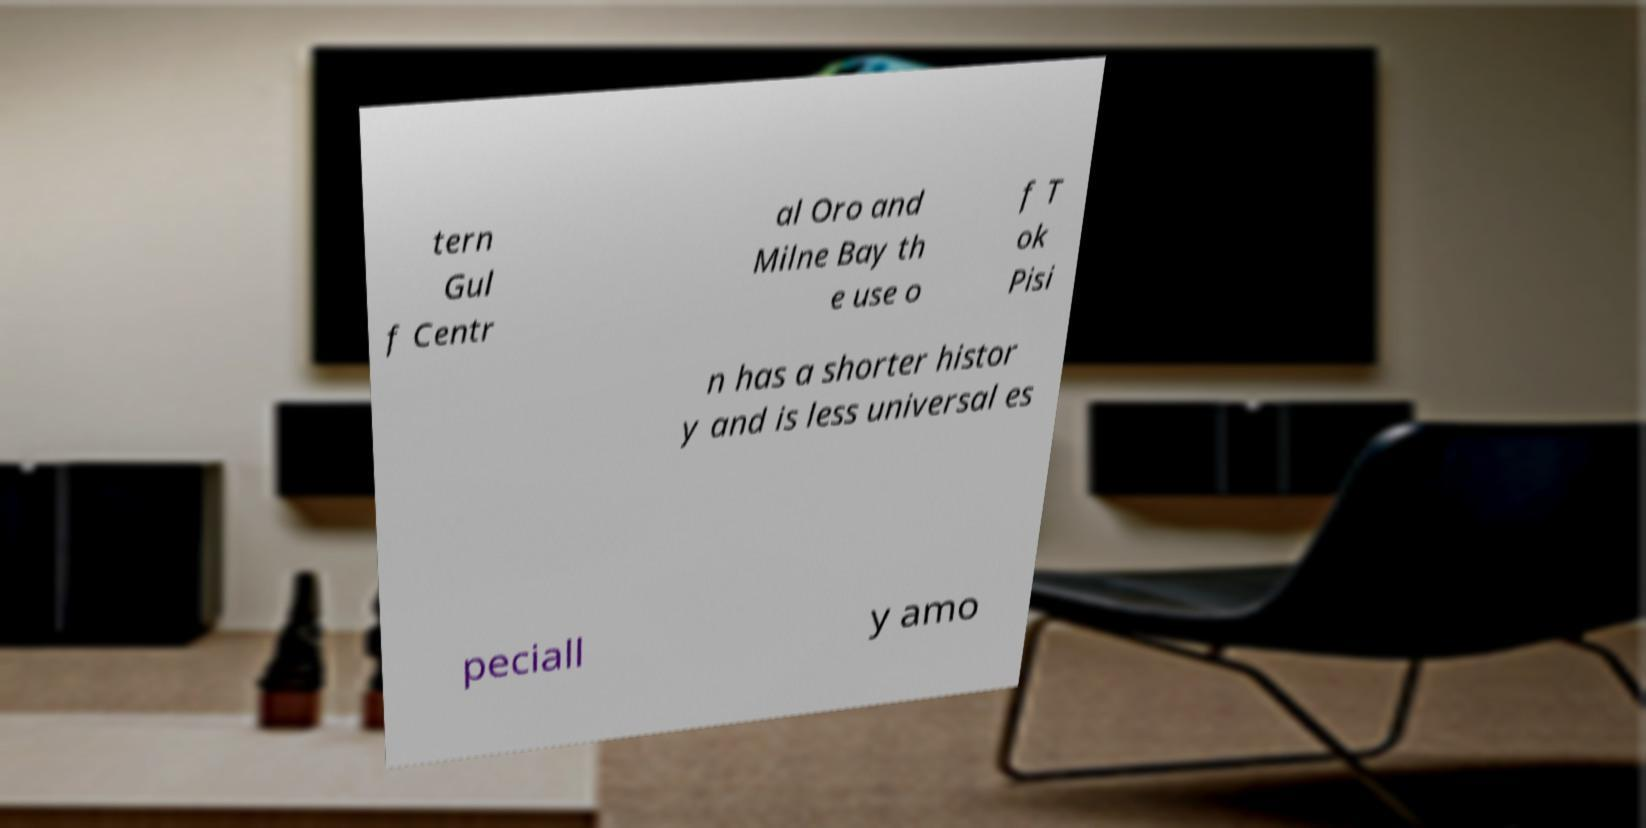Please identify and transcribe the text found in this image. tern Gul f Centr al Oro and Milne Bay th e use o f T ok Pisi n has a shorter histor y and is less universal es peciall y amo 